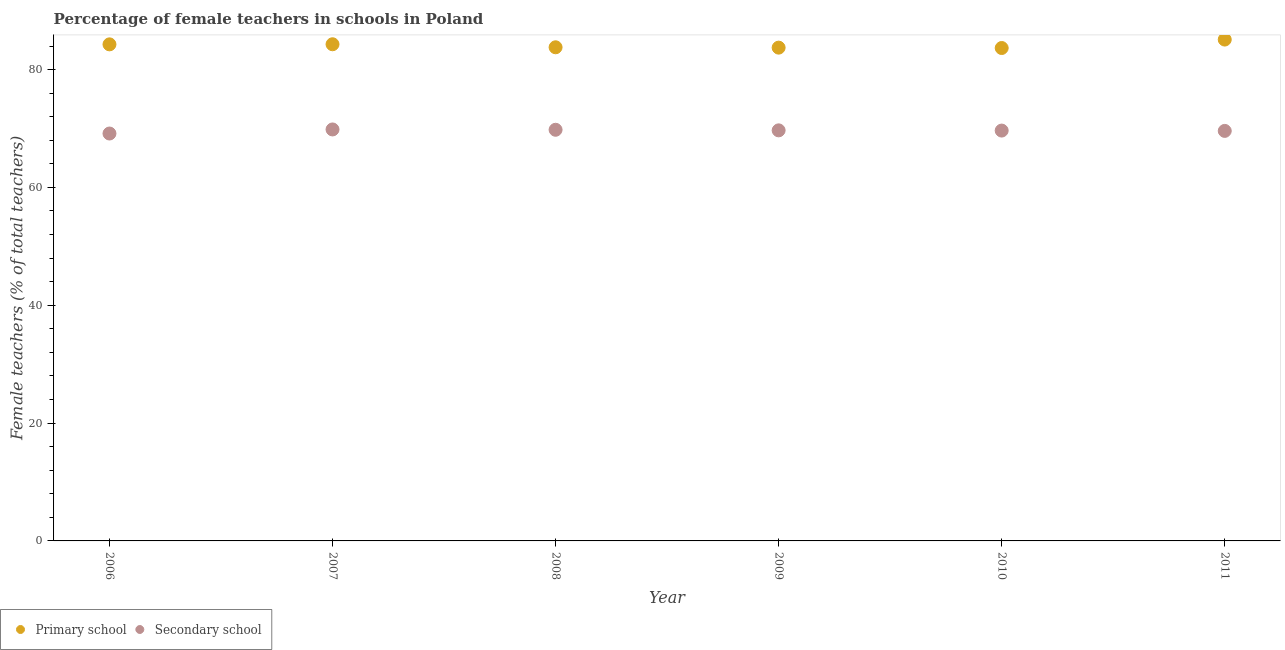What is the percentage of female teachers in secondary schools in 2009?
Your answer should be compact. 69.69. Across all years, what is the maximum percentage of female teachers in secondary schools?
Offer a terse response. 69.84. Across all years, what is the minimum percentage of female teachers in primary schools?
Offer a terse response. 83.66. In which year was the percentage of female teachers in primary schools maximum?
Ensure brevity in your answer.  2011. In which year was the percentage of female teachers in secondary schools minimum?
Provide a short and direct response. 2006. What is the total percentage of female teachers in primary schools in the graph?
Ensure brevity in your answer.  504.87. What is the difference between the percentage of female teachers in primary schools in 2006 and that in 2010?
Make the answer very short. 0.62. What is the difference between the percentage of female teachers in secondary schools in 2007 and the percentage of female teachers in primary schools in 2009?
Keep it short and to the point. -13.89. What is the average percentage of female teachers in secondary schools per year?
Keep it short and to the point. 69.62. In the year 2010, what is the difference between the percentage of female teachers in secondary schools and percentage of female teachers in primary schools?
Your answer should be compact. -14.01. In how many years, is the percentage of female teachers in secondary schools greater than 28 %?
Your answer should be compact. 6. What is the ratio of the percentage of female teachers in secondary schools in 2006 to that in 2008?
Offer a very short reply. 0.99. Is the percentage of female teachers in secondary schools in 2008 less than that in 2011?
Provide a succinct answer. No. Is the difference between the percentage of female teachers in primary schools in 2006 and 2007 greater than the difference between the percentage of female teachers in secondary schools in 2006 and 2007?
Your answer should be compact. Yes. What is the difference between the highest and the second highest percentage of female teachers in secondary schools?
Keep it short and to the point. 0.05. What is the difference between the highest and the lowest percentage of female teachers in primary schools?
Your response must be concise. 1.43. Does the percentage of female teachers in secondary schools monotonically increase over the years?
Give a very brief answer. No. Is the percentage of female teachers in primary schools strictly less than the percentage of female teachers in secondary schools over the years?
Offer a very short reply. No. How many years are there in the graph?
Your answer should be compact. 6. What is the difference between two consecutive major ticks on the Y-axis?
Give a very brief answer. 20. Does the graph contain any zero values?
Your answer should be very brief. No. Where does the legend appear in the graph?
Your response must be concise. Bottom left. How many legend labels are there?
Give a very brief answer. 2. What is the title of the graph?
Ensure brevity in your answer.  Percentage of female teachers in schools in Poland. Does "current US$" appear as one of the legend labels in the graph?
Ensure brevity in your answer.  No. What is the label or title of the Y-axis?
Make the answer very short. Female teachers (% of total teachers). What is the Female teachers (% of total teachers) in Primary school in 2006?
Offer a very short reply. 84.29. What is the Female teachers (% of total teachers) in Secondary school in 2006?
Ensure brevity in your answer.  69.15. What is the Female teachers (% of total teachers) of Primary school in 2007?
Your response must be concise. 84.3. What is the Female teachers (% of total teachers) in Secondary school in 2007?
Ensure brevity in your answer.  69.84. What is the Female teachers (% of total teachers) of Primary school in 2008?
Give a very brief answer. 83.79. What is the Female teachers (% of total teachers) in Secondary school in 2008?
Make the answer very short. 69.79. What is the Female teachers (% of total teachers) in Primary school in 2009?
Your answer should be very brief. 83.73. What is the Female teachers (% of total teachers) of Secondary school in 2009?
Make the answer very short. 69.69. What is the Female teachers (% of total teachers) of Primary school in 2010?
Your answer should be compact. 83.66. What is the Female teachers (% of total teachers) of Secondary school in 2010?
Keep it short and to the point. 69.65. What is the Female teachers (% of total teachers) in Primary school in 2011?
Ensure brevity in your answer.  85.1. What is the Female teachers (% of total teachers) of Secondary school in 2011?
Give a very brief answer. 69.6. Across all years, what is the maximum Female teachers (% of total teachers) in Primary school?
Provide a short and direct response. 85.1. Across all years, what is the maximum Female teachers (% of total teachers) of Secondary school?
Make the answer very short. 69.84. Across all years, what is the minimum Female teachers (% of total teachers) of Primary school?
Provide a succinct answer. 83.66. Across all years, what is the minimum Female teachers (% of total teachers) of Secondary school?
Give a very brief answer. 69.15. What is the total Female teachers (% of total teachers) in Primary school in the graph?
Ensure brevity in your answer.  504.87. What is the total Female teachers (% of total teachers) in Secondary school in the graph?
Keep it short and to the point. 417.72. What is the difference between the Female teachers (% of total teachers) of Primary school in 2006 and that in 2007?
Make the answer very short. -0.02. What is the difference between the Female teachers (% of total teachers) in Secondary school in 2006 and that in 2007?
Your answer should be very brief. -0.69. What is the difference between the Female teachers (% of total teachers) of Primary school in 2006 and that in 2008?
Ensure brevity in your answer.  0.5. What is the difference between the Female teachers (% of total teachers) in Secondary school in 2006 and that in 2008?
Your response must be concise. -0.64. What is the difference between the Female teachers (% of total teachers) of Primary school in 2006 and that in 2009?
Ensure brevity in your answer.  0.56. What is the difference between the Female teachers (% of total teachers) of Secondary school in 2006 and that in 2009?
Your answer should be compact. -0.54. What is the difference between the Female teachers (% of total teachers) in Primary school in 2006 and that in 2010?
Your answer should be very brief. 0.62. What is the difference between the Female teachers (% of total teachers) of Secondary school in 2006 and that in 2010?
Keep it short and to the point. -0.5. What is the difference between the Female teachers (% of total teachers) of Primary school in 2006 and that in 2011?
Keep it short and to the point. -0.81. What is the difference between the Female teachers (% of total teachers) of Secondary school in 2006 and that in 2011?
Give a very brief answer. -0.44. What is the difference between the Female teachers (% of total teachers) of Primary school in 2007 and that in 2008?
Your answer should be very brief. 0.51. What is the difference between the Female teachers (% of total teachers) of Secondary school in 2007 and that in 2008?
Provide a succinct answer. 0.05. What is the difference between the Female teachers (% of total teachers) of Primary school in 2007 and that in 2009?
Offer a very short reply. 0.57. What is the difference between the Female teachers (% of total teachers) in Secondary school in 2007 and that in 2009?
Give a very brief answer. 0.15. What is the difference between the Female teachers (% of total teachers) of Primary school in 2007 and that in 2010?
Your response must be concise. 0.64. What is the difference between the Female teachers (% of total teachers) in Secondary school in 2007 and that in 2010?
Make the answer very short. 0.19. What is the difference between the Female teachers (% of total teachers) in Primary school in 2007 and that in 2011?
Offer a very short reply. -0.8. What is the difference between the Female teachers (% of total teachers) in Secondary school in 2007 and that in 2011?
Provide a short and direct response. 0.25. What is the difference between the Female teachers (% of total teachers) in Primary school in 2008 and that in 2009?
Ensure brevity in your answer.  0.06. What is the difference between the Female teachers (% of total teachers) of Secondary school in 2008 and that in 2009?
Provide a succinct answer. 0.1. What is the difference between the Female teachers (% of total teachers) of Primary school in 2008 and that in 2010?
Ensure brevity in your answer.  0.12. What is the difference between the Female teachers (% of total teachers) of Secondary school in 2008 and that in 2010?
Give a very brief answer. 0.14. What is the difference between the Female teachers (% of total teachers) of Primary school in 2008 and that in 2011?
Your response must be concise. -1.31. What is the difference between the Female teachers (% of total teachers) of Secondary school in 2008 and that in 2011?
Your answer should be very brief. 0.19. What is the difference between the Female teachers (% of total teachers) in Primary school in 2009 and that in 2010?
Your answer should be compact. 0.06. What is the difference between the Female teachers (% of total teachers) of Secondary school in 2009 and that in 2010?
Give a very brief answer. 0.04. What is the difference between the Female teachers (% of total teachers) of Primary school in 2009 and that in 2011?
Your answer should be compact. -1.37. What is the difference between the Female teachers (% of total teachers) in Secondary school in 2009 and that in 2011?
Provide a short and direct response. 0.09. What is the difference between the Female teachers (% of total teachers) of Primary school in 2010 and that in 2011?
Make the answer very short. -1.43. What is the difference between the Female teachers (% of total teachers) in Secondary school in 2010 and that in 2011?
Your response must be concise. 0.05. What is the difference between the Female teachers (% of total teachers) in Primary school in 2006 and the Female teachers (% of total teachers) in Secondary school in 2007?
Your answer should be very brief. 14.44. What is the difference between the Female teachers (% of total teachers) of Primary school in 2006 and the Female teachers (% of total teachers) of Secondary school in 2008?
Provide a short and direct response. 14.5. What is the difference between the Female teachers (% of total teachers) in Primary school in 2006 and the Female teachers (% of total teachers) in Secondary school in 2009?
Your answer should be compact. 14.6. What is the difference between the Female teachers (% of total teachers) in Primary school in 2006 and the Female teachers (% of total teachers) in Secondary school in 2010?
Offer a terse response. 14.64. What is the difference between the Female teachers (% of total teachers) of Primary school in 2006 and the Female teachers (% of total teachers) of Secondary school in 2011?
Your response must be concise. 14.69. What is the difference between the Female teachers (% of total teachers) in Primary school in 2007 and the Female teachers (% of total teachers) in Secondary school in 2008?
Make the answer very short. 14.52. What is the difference between the Female teachers (% of total teachers) of Primary school in 2007 and the Female teachers (% of total teachers) of Secondary school in 2009?
Ensure brevity in your answer.  14.61. What is the difference between the Female teachers (% of total teachers) of Primary school in 2007 and the Female teachers (% of total teachers) of Secondary school in 2010?
Offer a very short reply. 14.65. What is the difference between the Female teachers (% of total teachers) in Primary school in 2007 and the Female teachers (% of total teachers) in Secondary school in 2011?
Provide a short and direct response. 14.71. What is the difference between the Female teachers (% of total teachers) of Primary school in 2008 and the Female teachers (% of total teachers) of Secondary school in 2009?
Provide a short and direct response. 14.1. What is the difference between the Female teachers (% of total teachers) of Primary school in 2008 and the Female teachers (% of total teachers) of Secondary school in 2010?
Offer a very short reply. 14.14. What is the difference between the Female teachers (% of total teachers) in Primary school in 2008 and the Female teachers (% of total teachers) in Secondary school in 2011?
Provide a short and direct response. 14.19. What is the difference between the Female teachers (% of total teachers) in Primary school in 2009 and the Female teachers (% of total teachers) in Secondary school in 2010?
Offer a very short reply. 14.08. What is the difference between the Female teachers (% of total teachers) of Primary school in 2009 and the Female teachers (% of total teachers) of Secondary school in 2011?
Make the answer very short. 14.13. What is the difference between the Female teachers (% of total teachers) of Primary school in 2010 and the Female teachers (% of total teachers) of Secondary school in 2011?
Offer a terse response. 14.07. What is the average Female teachers (% of total teachers) in Primary school per year?
Offer a very short reply. 84.14. What is the average Female teachers (% of total teachers) in Secondary school per year?
Provide a short and direct response. 69.62. In the year 2006, what is the difference between the Female teachers (% of total teachers) of Primary school and Female teachers (% of total teachers) of Secondary school?
Give a very brief answer. 15.13. In the year 2007, what is the difference between the Female teachers (% of total teachers) of Primary school and Female teachers (% of total teachers) of Secondary school?
Offer a very short reply. 14.46. In the year 2008, what is the difference between the Female teachers (% of total teachers) of Primary school and Female teachers (% of total teachers) of Secondary school?
Keep it short and to the point. 14. In the year 2009, what is the difference between the Female teachers (% of total teachers) in Primary school and Female teachers (% of total teachers) in Secondary school?
Ensure brevity in your answer.  14.04. In the year 2010, what is the difference between the Female teachers (% of total teachers) in Primary school and Female teachers (% of total teachers) in Secondary school?
Ensure brevity in your answer.  14.01. In the year 2011, what is the difference between the Female teachers (% of total teachers) of Primary school and Female teachers (% of total teachers) of Secondary school?
Your answer should be compact. 15.5. What is the ratio of the Female teachers (% of total teachers) of Secondary school in 2006 to that in 2007?
Your response must be concise. 0.99. What is the ratio of the Female teachers (% of total teachers) of Primary school in 2006 to that in 2008?
Your answer should be very brief. 1.01. What is the ratio of the Female teachers (% of total teachers) in Secondary school in 2006 to that in 2008?
Offer a very short reply. 0.99. What is the ratio of the Female teachers (% of total teachers) of Secondary school in 2006 to that in 2009?
Ensure brevity in your answer.  0.99. What is the ratio of the Female teachers (% of total teachers) of Primary school in 2006 to that in 2010?
Ensure brevity in your answer.  1.01. What is the ratio of the Female teachers (% of total teachers) of Primary school in 2006 to that in 2011?
Offer a terse response. 0.99. What is the ratio of the Female teachers (% of total teachers) of Secondary school in 2006 to that in 2011?
Your response must be concise. 0.99. What is the ratio of the Female teachers (% of total teachers) in Secondary school in 2007 to that in 2008?
Your answer should be very brief. 1. What is the ratio of the Female teachers (% of total teachers) of Secondary school in 2007 to that in 2009?
Ensure brevity in your answer.  1. What is the ratio of the Female teachers (% of total teachers) of Primary school in 2007 to that in 2010?
Your answer should be very brief. 1.01. What is the ratio of the Female teachers (% of total teachers) of Primary school in 2007 to that in 2011?
Give a very brief answer. 0.99. What is the ratio of the Female teachers (% of total teachers) of Secondary school in 2007 to that in 2011?
Ensure brevity in your answer.  1. What is the ratio of the Female teachers (% of total teachers) in Secondary school in 2008 to that in 2010?
Offer a very short reply. 1. What is the ratio of the Female teachers (% of total teachers) in Primary school in 2008 to that in 2011?
Ensure brevity in your answer.  0.98. What is the ratio of the Female teachers (% of total teachers) of Secondary school in 2008 to that in 2011?
Ensure brevity in your answer.  1. What is the ratio of the Female teachers (% of total teachers) of Secondary school in 2009 to that in 2010?
Ensure brevity in your answer.  1. What is the ratio of the Female teachers (% of total teachers) of Primary school in 2009 to that in 2011?
Offer a terse response. 0.98. What is the ratio of the Female teachers (% of total teachers) of Primary school in 2010 to that in 2011?
Provide a short and direct response. 0.98. What is the ratio of the Female teachers (% of total teachers) of Secondary school in 2010 to that in 2011?
Provide a succinct answer. 1. What is the difference between the highest and the second highest Female teachers (% of total teachers) in Primary school?
Offer a terse response. 0.8. What is the difference between the highest and the second highest Female teachers (% of total teachers) of Secondary school?
Make the answer very short. 0.05. What is the difference between the highest and the lowest Female teachers (% of total teachers) in Primary school?
Give a very brief answer. 1.43. What is the difference between the highest and the lowest Female teachers (% of total teachers) in Secondary school?
Make the answer very short. 0.69. 